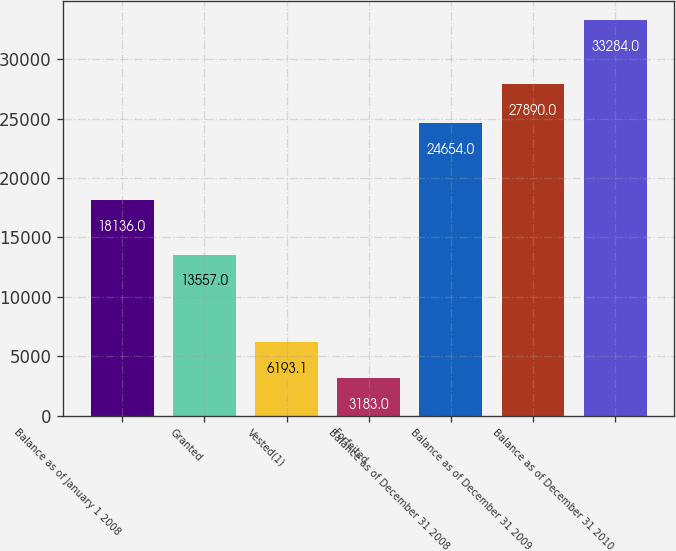Convert chart to OTSL. <chart><loc_0><loc_0><loc_500><loc_500><bar_chart><fcel>Balance as of January 1 2008<fcel>Granted<fcel>Vested(1)<fcel>Forfeited<fcel>Balance as of December 31 2008<fcel>Balance as of December 31 2009<fcel>Balance as of December 31 2010<nl><fcel>18136<fcel>13557<fcel>6193.1<fcel>3183<fcel>24654<fcel>27890<fcel>33284<nl></chart> 